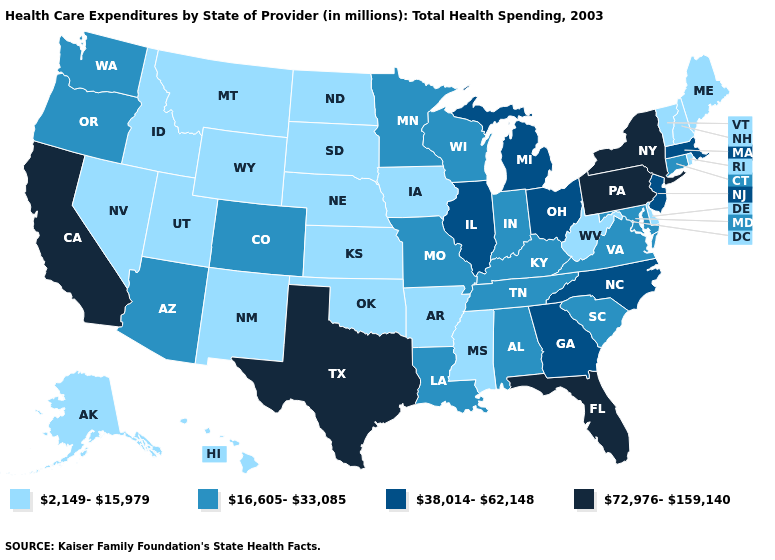Name the states that have a value in the range 2,149-15,979?
Give a very brief answer. Alaska, Arkansas, Delaware, Hawaii, Idaho, Iowa, Kansas, Maine, Mississippi, Montana, Nebraska, Nevada, New Hampshire, New Mexico, North Dakota, Oklahoma, Rhode Island, South Dakota, Utah, Vermont, West Virginia, Wyoming. Name the states that have a value in the range 16,605-33,085?
Write a very short answer. Alabama, Arizona, Colorado, Connecticut, Indiana, Kentucky, Louisiana, Maryland, Minnesota, Missouri, Oregon, South Carolina, Tennessee, Virginia, Washington, Wisconsin. What is the value of Indiana?
Short answer required. 16,605-33,085. Does Ohio have a lower value than Florida?
Concise answer only. Yes. Does Arkansas have a lower value than New Jersey?
Write a very short answer. Yes. Which states have the lowest value in the Northeast?
Be succinct. Maine, New Hampshire, Rhode Island, Vermont. What is the highest value in states that border Wyoming?
Write a very short answer. 16,605-33,085. Name the states that have a value in the range 38,014-62,148?
Answer briefly. Georgia, Illinois, Massachusetts, Michigan, New Jersey, North Carolina, Ohio. Does Nebraska have the highest value in the MidWest?
Write a very short answer. No. What is the value of South Carolina?
Quick response, please. 16,605-33,085. What is the value of Oregon?
Write a very short answer. 16,605-33,085. Among the states that border Montana , which have the lowest value?
Answer briefly. Idaho, North Dakota, South Dakota, Wyoming. Which states have the highest value in the USA?
Be succinct. California, Florida, New York, Pennsylvania, Texas. Does Maine have the lowest value in the Northeast?
Give a very brief answer. Yes. Name the states that have a value in the range 16,605-33,085?
Write a very short answer. Alabama, Arizona, Colorado, Connecticut, Indiana, Kentucky, Louisiana, Maryland, Minnesota, Missouri, Oregon, South Carolina, Tennessee, Virginia, Washington, Wisconsin. 